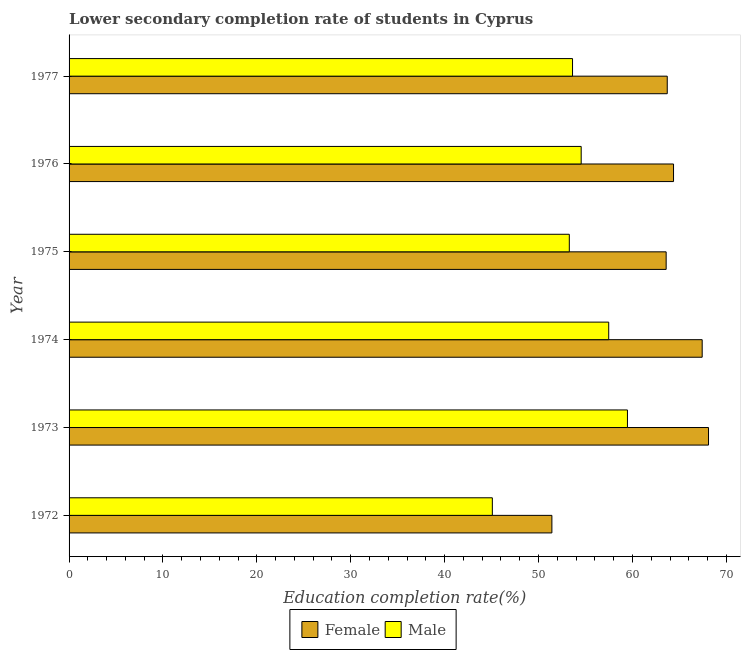Are the number of bars per tick equal to the number of legend labels?
Keep it short and to the point. Yes. Are the number of bars on each tick of the Y-axis equal?
Offer a very short reply. Yes. How many bars are there on the 3rd tick from the top?
Your response must be concise. 2. What is the education completion rate of male students in 1972?
Your response must be concise. 45.08. Across all years, what is the maximum education completion rate of male students?
Offer a terse response. 59.47. Across all years, what is the minimum education completion rate of male students?
Keep it short and to the point. 45.08. In which year was the education completion rate of male students maximum?
Give a very brief answer. 1973. What is the total education completion rate of female students in the graph?
Keep it short and to the point. 378.62. What is the difference between the education completion rate of male students in 1972 and that in 1973?
Provide a short and direct response. -14.39. What is the difference between the education completion rate of male students in 1975 and the education completion rate of female students in 1974?
Your answer should be compact. -14.15. What is the average education completion rate of male students per year?
Provide a succinct answer. 53.91. In the year 1976, what is the difference between the education completion rate of female students and education completion rate of male students?
Provide a succinct answer. 9.83. In how many years, is the education completion rate of male students greater than 18 %?
Keep it short and to the point. 6. What is the ratio of the education completion rate of male students in 1973 to that in 1977?
Provide a short and direct response. 1.11. Is the education completion rate of female students in 1972 less than that in 1973?
Offer a terse response. Yes. Is the difference between the education completion rate of female students in 1973 and 1974 greater than the difference between the education completion rate of male students in 1973 and 1974?
Your response must be concise. No. What is the difference between the highest and the second highest education completion rate of male students?
Provide a short and direct response. 2. What is the difference between the highest and the lowest education completion rate of female students?
Make the answer very short. 16.68. What does the 2nd bar from the bottom in 1973 represents?
Your answer should be compact. Male. Are all the bars in the graph horizontal?
Keep it short and to the point. Yes. What is the difference between two consecutive major ticks on the X-axis?
Offer a terse response. 10. Does the graph contain grids?
Your response must be concise. No. How many legend labels are there?
Offer a very short reply. 2. What is the title of the graph?
Your answer should be compact. Lower secondary completion rate of students in Cyprus. What is the label or title of the X-axis?
Offer a terse response. Education completion rate(%). What is the Education completion rate(%) of Female in 1972?
Provide a short and direct response. 51.42. What is the Education completion rate(%) of Male in 1972?
Make the answer very short. 45.08. What is the Education completion rate(%) of Female in 1973?
Keep it short and to the point. 68.1. What is the Education completion rate(%) of Male in 1973?
Give a very brief answer. 59.47. What is the Education completion rate(%) in Female in 1974?
Offer a very short reply. 67.43. What is the Education completion rate(%) of Male in 1974?
Keep it short and to the point. 57.47. What is the Education completion rate(%) in Female in 1975?
Keep it short and to the point. 63.59. What is the Education completion rate(%) in Male in 1975?
Give a very brief answer. 53.28. What is the Education completion rate(%) in Female in 1976?
Offer a terse response. 64.38. What is the Education completion rate(%) of Male in 1976?
Offer a terse response. 54.54. What is the Education completion rate(%) in Female in 1977?
Offer a very short reply. 63.71. What is the Education completion rate(%) in Male in 1977?
Make the answer very short. 53.62. Across all years, what is the maximum Education completion rate(%) in Female?
Offer a very short reply. 68.1. Across all years, what is the maximum Education completion rate(%) in Male?
Ensure brevity in your answer.  59.47. Across all years, what is the minimum Education completion rate(%) of Female?
Provide a short and direct response. 51.42. Across all years, what is the minimum Education completion rate(%) in Male?
Give a very brief answer. 45.08. What is the total Education completion rate(%) of Female in the graph?
Give a very brief answer. 378.62. What is the total Education completion rate(%) of Male in the graph?
Your answer should be very brief. 323.46. What is the difference between the Education completion rate(%) in Female in 1972 and that in 1973?
Provide a short and direct response. -16.68. What is the difference between the Education completion rate(%) of Male in 1972 and that in 1973?
Offer a very short reply. -14.39. What is the difference between the Education completion rate(%) of Female in 1972 and that in 1974?
Offer a terse response. -16.01. What is the difference between the Education completion rate(%) of Male in 1972 and that in 1974?
Ensure brevity in your answer.  -12.39. What is the difference between the Education completion rate(%) of Female in 1972 and that in 1975?
Your response must be concise. -12.17. What is the difference between the Education completion rate(%) in Male in 1972 and that in 1975?
Your answer should be very brief. -8.2. What is the difference between the Education completion rate(%) in Female in 1972 and that in 1976?
Provide a short and direct response. -12.95. What is the difference between the Education completion rate(%) of Male in 1972 and that in 1976?
Offer a terse response. -9.46. What is the difference between the Education completion rate(%) of Female in 1972 and that in 1977?
Provide a short and direct response. -12.29. What is the difference between the Education completion rate(%) in Male in 1972 and that in 1977?
Give a very brief answer. -8.54. What is the difference between the Education completion rate(%) of Female in 1973 and that in 1974?
Provide a short and direct response. 0.67. What is the difference between the Education completion rate(%) in Male in 1973 and that in 1974?
Provide a succinct answer. 2. What is the difference between the Education completion rate(%) in Female in 1973 and that in 1975?
Give a very brief answer. 4.51. What is the difference between the Education completion rate(%) in Male in 1973 and that in 1975?
Keep it short and to the point. 6.19. What is the difference between the Education completion rate(%) in Female in 1973 and that in 1976?
Your answer should be compact. 3.73. What is the difference between the Education completion rate(%) in Male in 1973 and that in 1976?
Your response must be concise. 4.93. What is the difference between the Education completion rate(%) in Female in 1973 and that in 1977?
Your response must be concise. 4.4. What is the difference between the Education completion rate(%) of Male in 1973 and that in 1977?
Provide a succinct answer. 5.85. What is the difference between the Education completion rate(%) in Female in 1974 and that in 1975?
Offer a terse response. 3.84. What is the difference between the Education completion rate(%) in Male in 1974 and that in 1975?
Provide a succinct answer. 4.2. What is the difference between the Education completion rate(%) in Female in 1974 and that in 1976?
Provide a short and direct response. 3.05. What is the difference between the Education completion rate(%) of Male in 1974 and that in 1976?
Your answer should be very brief. 2.93. What is the difference between the Education completion rate(%) in Female in 1974 and that in 1977?
Give a very brief answer. 3.72. What is the difference between the Education completion rate(%) in Male in 1974 and that in 1977?
Your answer should be very brief. 3.85. What is the difference between the Education completion rate(%) in Female in 1975 and that in 1976?
Provide a short and direct response. -0.78. What is the difference between the Education completion rate(%) of Male in 1975 and that in 1976?
Offer a very short reply. -1.26. What is the difference between the Education completion rate(%) in Female in 1975 and that in 1977?
Offer a very short reply. -0.12. What is the difference between the Education completion rate(%) of Male in 1975 and that in 1977?
Your answer should be compact. -0.34. What is the difference between the Education completion rate(%) of Female in 1976 and that in 1977?
Your answer should be very brief. 0.67. What is the difference between the Education completion rate(%) in Male in 1976 and that in 1977?
Make the answer very short. 0.92. What is the difference between the Education completion rate(%) in Female in 1972 and the Education completion rate(%) in Male in 1973?
Give a very brief answer. -8.05. What is the difference between the Education completion rate(%) of Female in 1972 and the Education completion rate(%) of Male in 1974?
Offer a very short reply. -6.05. What is the difference between the Education completion rate(%) of Female in 1972 and the Education completion rate(%) of Male in 1975?
Make the answer very short. -1.86. What is the difference between the Education completion rate(%) of Female in 1972 and the Education completion rate(%) of Male in 1976?
Offer a very short reply. -3.12. What is the difference between the Education completion rate(%) in Female in 1972 and the Education completion rate(%) in Male in 1977?
Your answer should be compact. -2.2. What is the difference between the Education completion rate(%) in Female in 1973 and the Education completion rate(%) in Male in 1974?
Keep it short and to the point. 10.63. What is the difference between the Education completion rate(%) in Female in 1973 and the Education completion rate(%) in Male in 1975?
Your answer should be very brief. 14.83. What is the difference between the Education completion rate(%) in Female in 1973 and the Education completion rate(%) in Male in 1976?
Ensure brevity in your answer.  13.56. What is the difference between the Education completion rate(%) in Female in 1973 and the Education completion rate(%) in Male in 1977?
Give a very brief answer. 14.48. What is the difference between the Education completion rate(%) in Female in 1974 and the Education completion rate(%) in Male in 1975?
Offer a terse response. 14.15. What is the difference between the Education completion rate(%) in Female in 1974 and the Education completion rate(%) in Male in 1976?
Offer a terse response. 12.89. What is the difference between the Education completion rate(%) in Female in 1974 and the Education completion rate(%) in Male in 1977?
Keep it short and to the point. 13.81. What is the difference between the Education completion rate(%) of Female in 1975 and the Education completion rate(%) of Male in 1976?
Give a very brief answer. 9.05. What is the difference between the Education completion rate(%) of Female in 1975 and the Education completion rate(%) of Male in 1977?
Offer a very short reply. 9.97. What is the difference between the Education completion rate(%) in Female in 1976 and the Education completion rate(%) in Male in 1977?
Give a very brief answer. 10.76. What is the average Education completion rate(%) of Female per year?
Provide a succinct answer. 63.1. What is the average Education completion rate(%) of Male per year?
Your answer should be compact. 53.91. In the year 1972, what is the difference between the Education completion rate(%) in Female and Education completion rate(%) in Male?
Your answer should be compact. 6.34. In the year 1973, what is the difference between the Education completion rate(%) of Female and Education completion rate(%) of Male?
Provide a succinct answer. 8.63. In the year 1974, what is the difference between the Education completion rate(%) of Female and Education completion rate(%) of Male?
Your answer should be compact. 9.95. In the year 1975, what is the difference between the Education completion rate(%) of Female and Education completion rate(%) of Male?
Give a very brief answer. 10.31. In the year 1976, what is the difference between the Education completion rate(%) in Female and Education completion rate(%) in Male?
Your response must be concise. 9.83. In the year 1977, what is the difference between the Education completion rate(%) of Female and Education completion rate(%) of Male?
Keep it short and to the point. 10.09. What is the ratio of the Education completion rate(%) of Female in 1972 to that in 1973?
Keep it short and to the point. 0.76. What is the ratio of the Education completion rate(%) of Male in 1972 to that in 1973?
Your answer should be compact. 0.76. What is the ratio of the Education completion rate(%) in Female in 1972 to that in 1974?
Provide a succinct answer. 0.76. What is the ratio of the Education completion rate(%) of Male in 1972 to that in 1974?
Provide a succinct answer. 0.78. What is the ratio of the Education completion rate(%) of Female in 1972 to that in 1975?
Offer a very short reply. 0.81. What is the ratio of the Education completion rate(%) in Male in 1972 to that in 1975?
Your response must be concise. 0.85. What is the ratio of the Education completion rate(%) of Female in 1972 to that in 1976?
Keep it short and to the point. 0.8. What is the ratio of the Education completion rate(%) of Male in 1972 to that in 1976?
Offer a very short reply. 0.83. What is the ratio of the Education completion rate(%) of Female in 1972 to that in 1977?
Offer a terse response. 0.81. What is the ratio of the Education completion rate(%) of Male in 1972 to that in 1977?
Your answer should be very brief. 0.84. What is the ratio of the Education completion rate(%) in Male in 1973 to that in 1974?
Make the answer very short. 1.03. What is the ratio of the Education completion rate(%) of Female in 1973 to that in 1975?
Offer a very short reply. 1.07. What is the ratio of the Education completion rate(%) of Male in 1973 to that in 1975?
Offer a very short reply. 1.12. What is the ratio of the Education completion rate(%) in Female in 1973 to that in 1976?
Offer a very short reply. 1.06. What is the ratio of the Education completion rate(%) in Male in 1973 to that in 1976?
Give a very brief answer. 1.09. What is the ratio of the Education completion rate(%) of Female in 1973 to that in 1977?
Provide a succinct answer. 1.07. What is the ratio of the Education completion rate(%) of Male in 1973 to that in 1977?
Keep it short and to the point. 1.11. What is the ratio of the Education completion rate(%) of Female in 1974 to that in 1975?
Make the answer very short. 1.06. What is the ratio of the Education completion rate(%) of Male in 1974 to that in 1975?
Keep it short and to the point. 1.08. What is the ratio of the Education completion rate(%) in Female in 1974 to that in 1976?
Offer a very short reply. 1.05. What is the ratio of the Education completion rate(%) in Male in 1974 to that in 1976?
Provide a short and direct response. 1.05. What is the ratio of the Education completion rate(%) of Female in 1974 to that in 1977?
Provide a short and direct response. 1.06. What is the ratio of the Education completion rate(%) in Male in 1974 to that in 1977?
Your answer should be compact. 1.07. What is the ratio of the Education completion rate(%) of Male in 1975 to that in 1976?
Offer a terse response. 0.98. What is the ratio of the Education completion rate(%) in Female in 1976 to that in 1977?
Your answer should be compact. 1.01. What is the ratio of the Education completion rate(%) of Male in 1976 to that in 1977?
Make the answer very short. 1.02. What is the difference between the highest and the second highest Education completion rate(%) in Female?
Offer a very short reply. 0.67. What is the difference between the highest and the second highest Education completion rate(%) of Male?
Offer a very short reply. 2. What is the difference between the highest and the lowest Education completion rate(%) in Female?
Make the answer very short. 16.68. What is the difference between the highest and the lowest Education completion rate(%) of Male?
Make the answer very short. 14.39. 